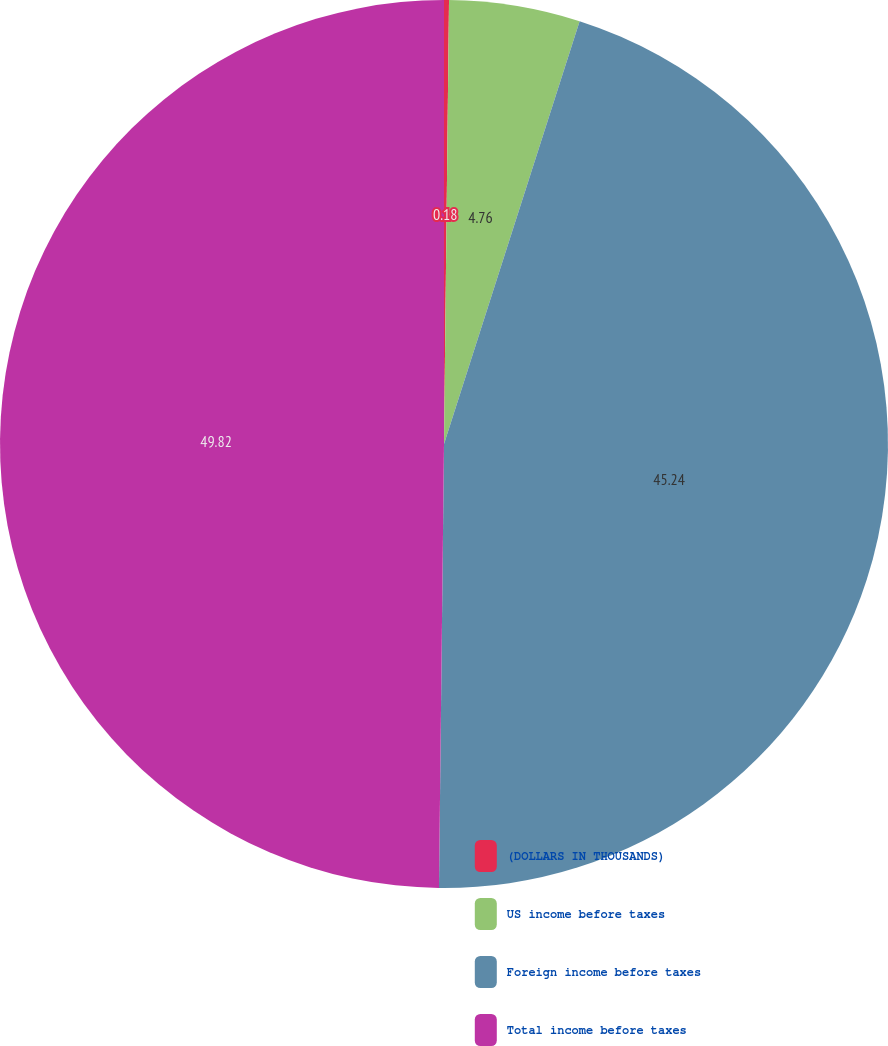Convert chart to OTSL. <chart><loc_0><loc_0><loc_500><loc_500><pie_chart><fcel>(DOLLARS IN THOUSANDS)<fcel>US income before taxes<fcel>Foreign income before taxes<fcel>Total income before taxes<nl><fcel>0.18%<fcel>4.76%<fcel>45.24%<fcel>49.82%<nl></chart> 